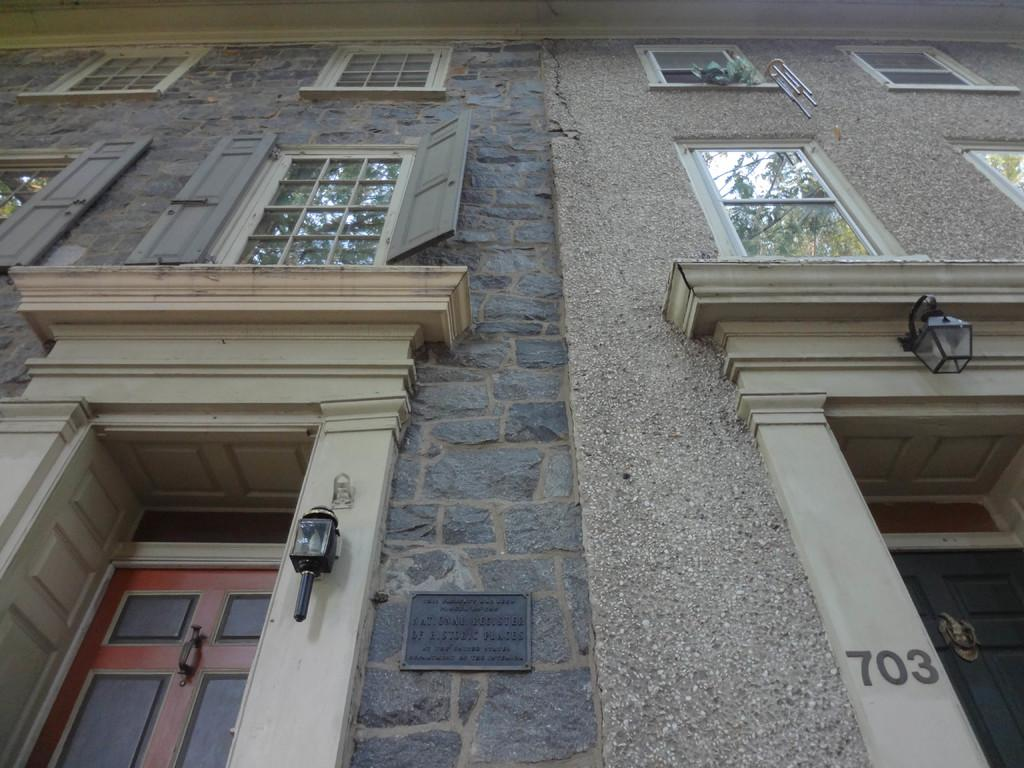What is the main subject of the image? The main subject of the image is a building. What part of the building can be seen in the image? The image is a view of the building from the front side. What features are visible on the building? There are doors, lamps, and glass windows visible in the image. What type of advertisement can be seen hanging from the lamps in the image? There is no advertisement present in the image; only doors, lamps, and glass windows are visible. Is there a garden visible in the image? There is no garden visible in the image; the focus is on the building and its features. 